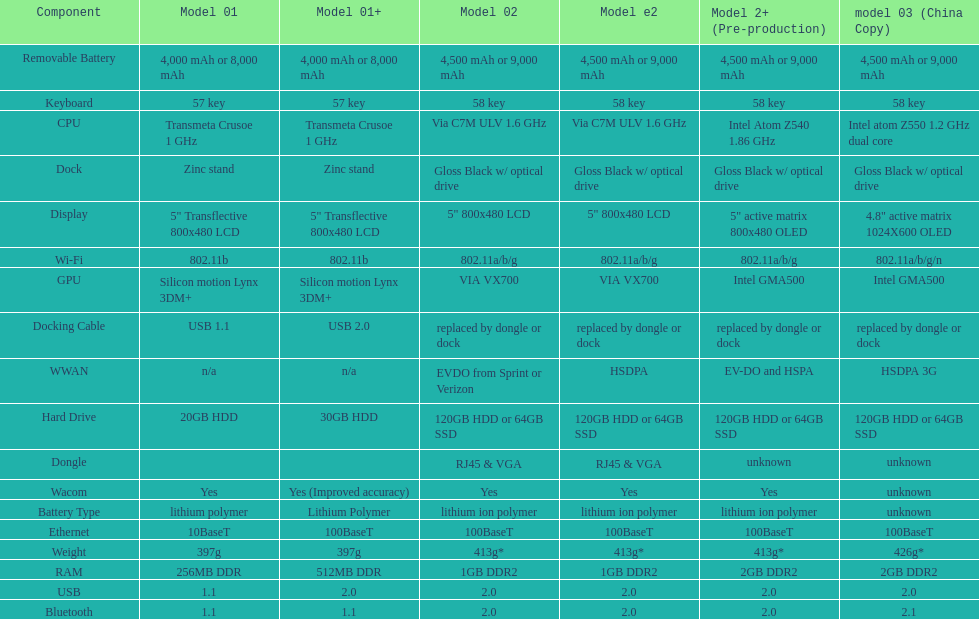What is the component before usb? Display. 